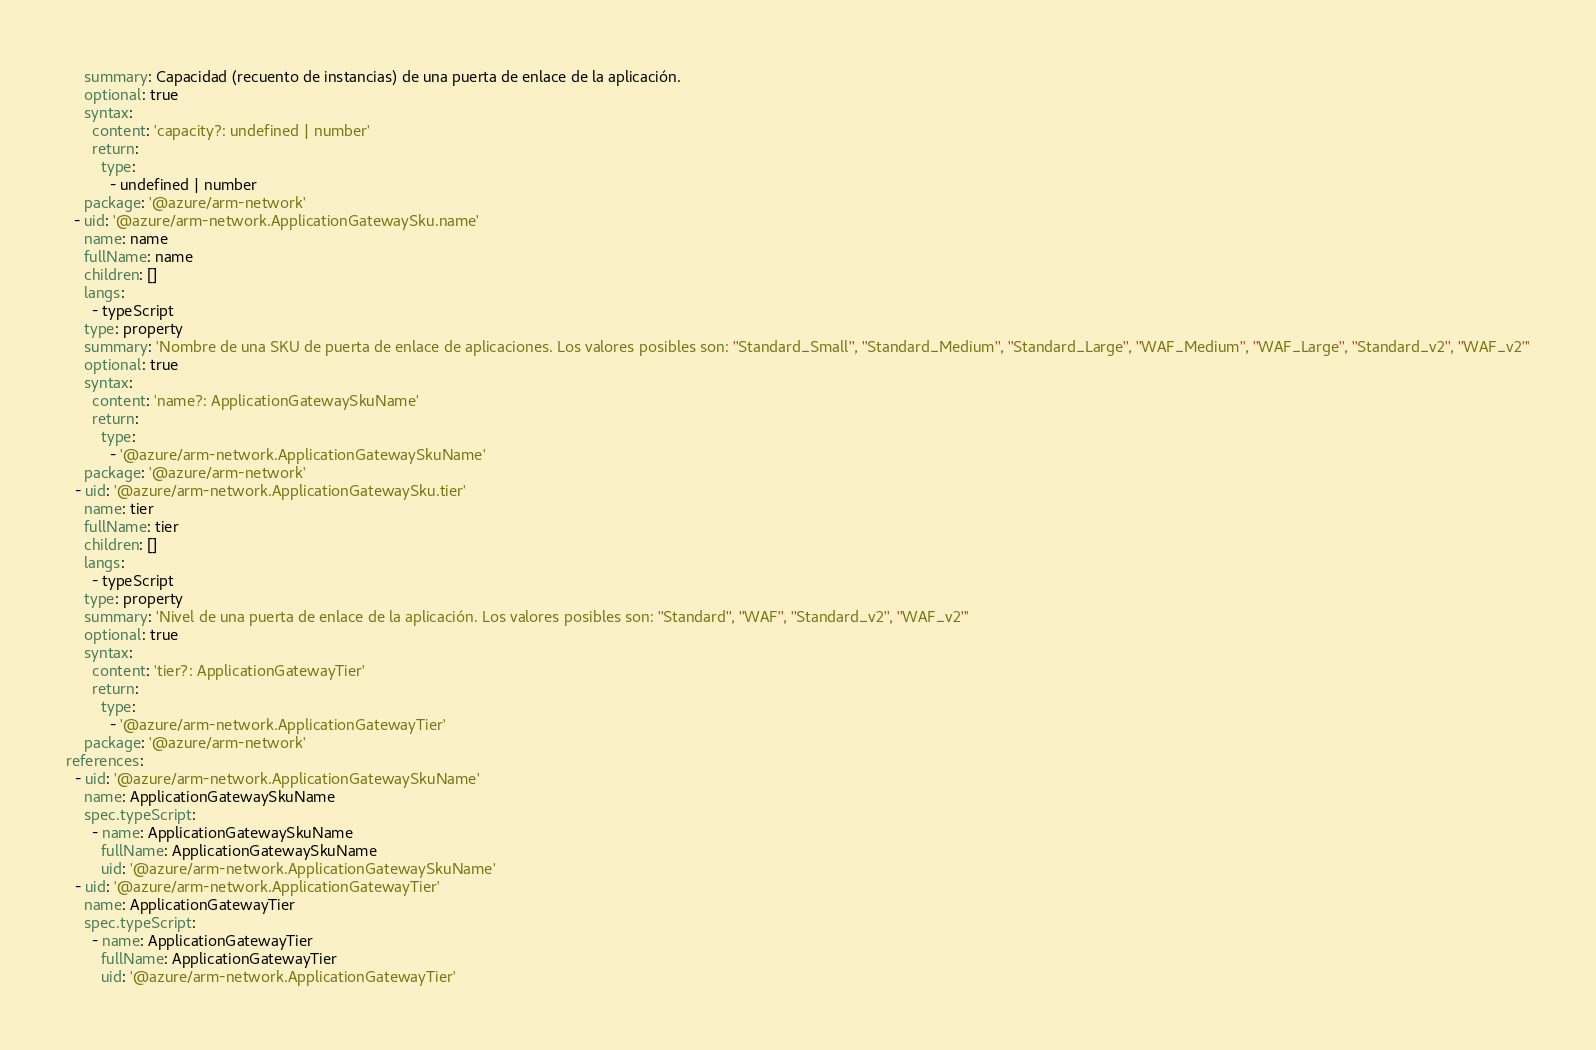Convert code to text. <code><loc_0><loc_0><loc_500><loc_500><_YAML_>    summary: Capacidad (recuento de instancias) de una puerta de enlace de la aplicación.
    optional: true
    syntax:
      content: 'capacity?: undefined | number'
      return:
        type:
          - undefined | number
    package: '@azure/arm-network'
  - uid: '@azure/arm-network.ApplicationGatewaySku.name'
    name: name
    fullName: name
    children: []
    langs:
      - typeScript
    type: property
    summary: 'Nombre de una SKU de puerta de enlace de aplicaciones. Los valores posibles son: ''Standard_Small'', ''Standard_Medium'', ''Standard_Large'', ''WAF_Medium'', ''WAF_Large'', ''Standard_v2'', ''WAF_v2'''
    optional: true
    syntax:
      content: 'name?: ApplicationGatewaySkuName'
      return:
        type:
          - '@azure/arm-network.ApplicationGatewaySkuName'
    package: '@azure/arm-network'
  - uid: '@azure/arm-network.ApplicationGatewaySku.tier'
    name: tier
    fullName: tier
    children: []
    langs:
      - typeScript
    type: property
    summary: 'Nivel de una puerta de enlace de la aplicación. Los valores posibles son: ''Standard'', ''WAF'', ''Standard_v2'', ''WAF_v2'''
    optional: true
    syntax:
      content: 'tier?: ApplicationGatewayTier'
      return:
        type:
          - '@azure/arm-network.ApplicationGatewayTier'
    package: '@azure/arm-network'
references:
  - uid: '@azure/arm-network.ApplicationGatewaySkuName'
    name: ApplicationGatewaySkuName
    spec.typeScript:
      - name: ApplicationGatewaySkuName
        fullName: ApplicationGatewaySkuName
        uid: '@azure/arm-network.ApplicationGatewaySkuName'
  - uid: '@azure/arm-network.ApplicationGatewayTier'
    name: ApplicationGatewayTier
    spec.typeScript:
      - name: ApplicationGatewayTier
        fullName: ApplicationGatewayTier
        uid: '@azure/arm-network.ApplicationGatewayTier'</code> 